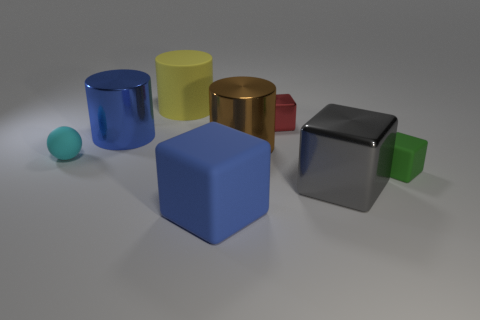Subtract all big blue blocks. How many blocks are left? 3 Subtract all blue blocks. How many blocks are left? 3 Add 2 large blue things. How many objects exist? 10 Subtract 3 cylinders. How many cylinders are left? 0 Subtract all cubes. Subtract all large red metal cubes. How many objects are left? 4 Add 5 blue cylinders. How many blue cylinders are left? 6 Add 5 big blue rubber things. How many big blue rubber things exist? 6 Subtract 0 brown cubes. How many objects are left? 8 Subtract all cylinders. How many objects are left? 5 Subtract all red cubes. Subtract all blue cylinders. How many cubes are left? 3 